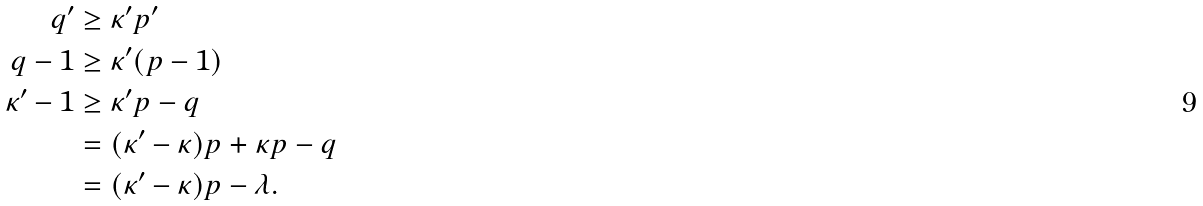<formula> <loc_0><loc_0><loc_500><loc_500>q ^ { \prime } & \geq \kappa ^ { \prime } p ^ { \prime } \\ q - 1 & \geq \kappa ^ { \prime } ( p - 1 ) \\ \kappa ^ { \prime } - 1 & \geq \kappa ^ { \prime } p - q \\ & = ( \kappa ^ { \prime } - \kappa ) p + \kappa p - q \\ & = ( \kappa ^ { \prime } - \kappa ) p - \lambda .</formula> 